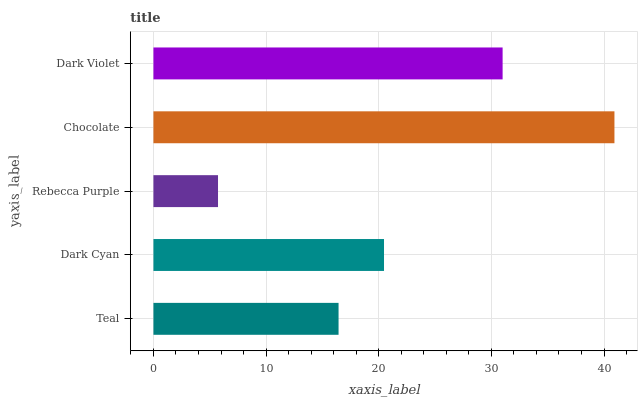Is Rebecca Purple the minimum?
Answer yes or no. Yes. Is Chocolate the maximum?
Answer yes or no. Yes. Is Dark Cyan the minimum?
Answer yes or no. No. Is Dark Cyan the maximum?
Answer yes or no. No. Is Dark Cyan greater than Teal?
Answer yes or no. Yes. Is Teal less than Dark Cyan?
Answer yes or no. Yes. Is Teal greater than Dark Cyan?
Answer yes or no. No. Is Dark Cyan less than Teal?
Answer yes or no. No. Is Dark Cyan the high median?
Answer yes or no. Yes. Is Dark Cyan the low median?
Answer yes or no. Yes. Is Rebecca Purple the high median?
Answer yes or no. No. Is Chocolate the low median?
Answer yes or no. No. 